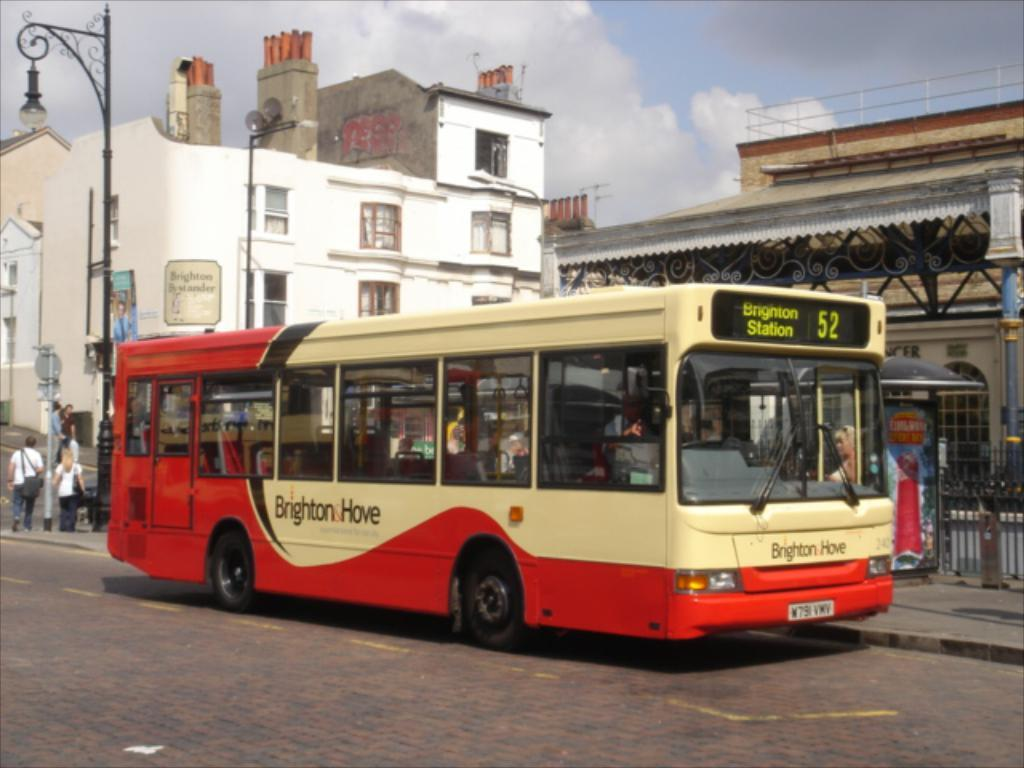<image>
Create a compact narrative representing the image presented. the bus with the number 52 on it 